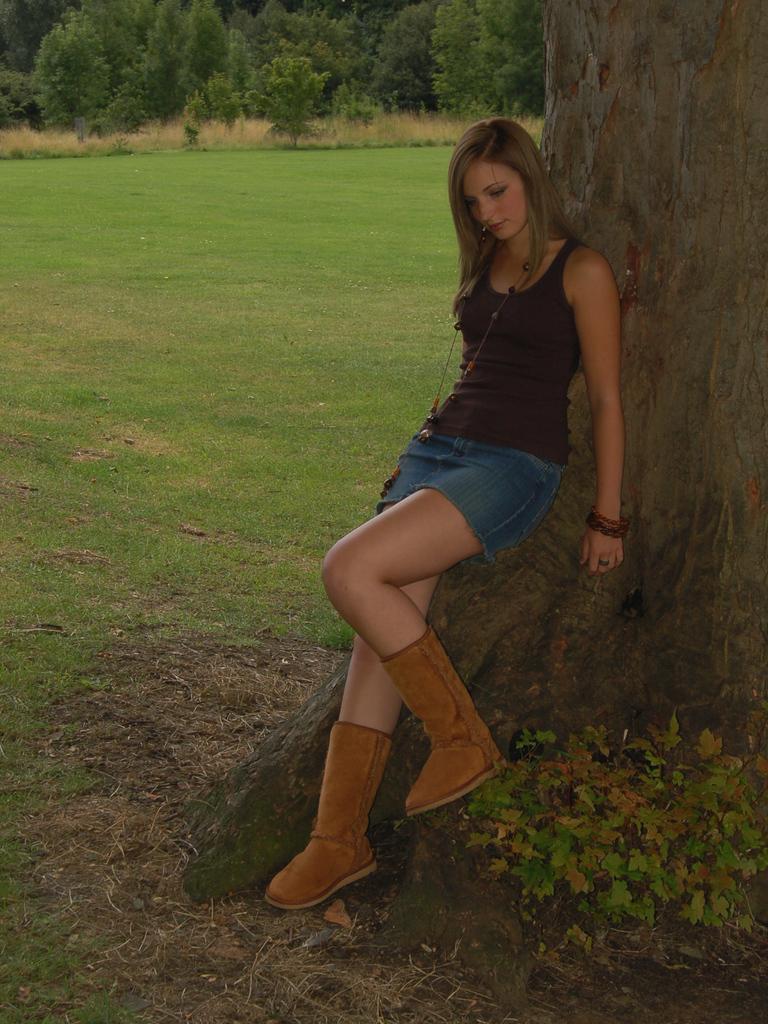How would you summarize this image in a sentence or two? As we can see in the image there is grass, trees, a woman wearing black color dress, pants and a tree stem. 